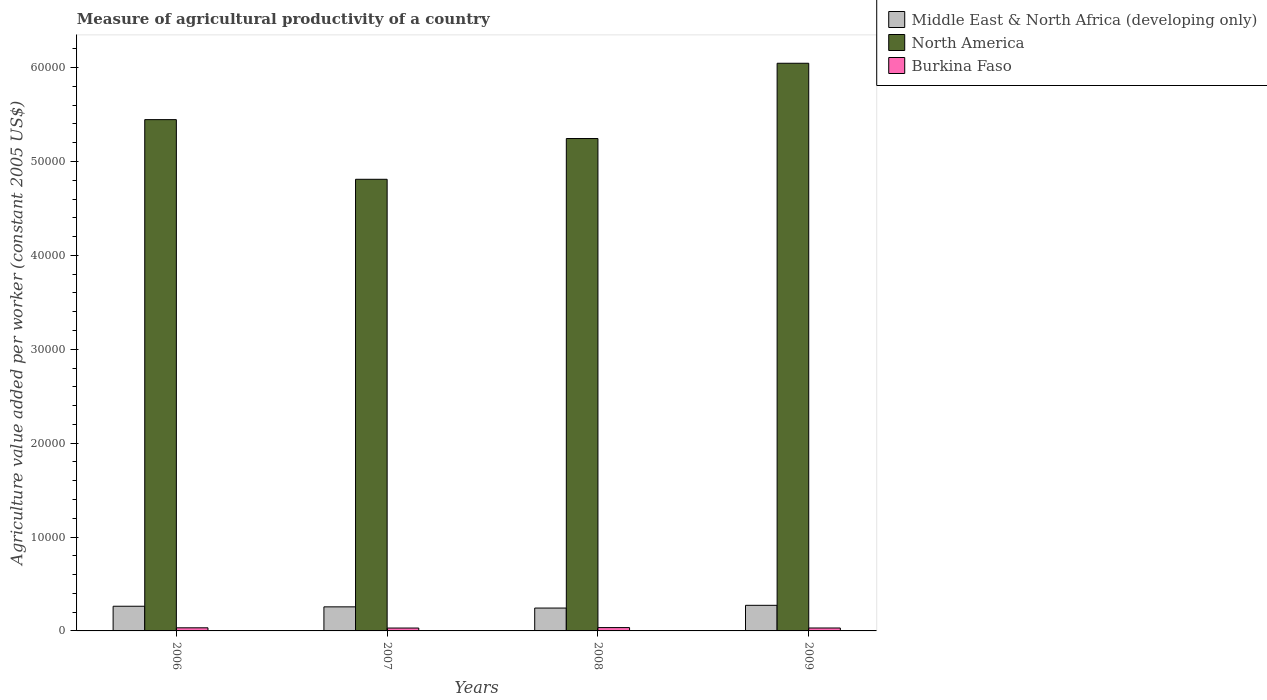How many groups of bars are there?
Give a very brief answer. 4. Are the number of bars per tick equal to the number of legend labels?
Offer a terse response. Yes. Are the number of bars on each tick of the X-axis equal?
Your answer should be very brief. Yes. What is the label of the 4th group of bars from the left?
Your answer should be very brief. 2009. In how many cases, is the number of bars for a given year not equal to the number of legend labels?
Your response must be concise. 0. What is the measure of agricultural productivity in Burkina Faso in 2008?
Your answer should be compact. 355.16. Across all years, what is the maximum measure of agricultural productivity in Middle East & North Africa (developing only)?
Provide a short and direct response. 2727.48. Across all years, what is the minimum measure of agricultural productivity in North America?
Provide a succinct answer. 4.81e+04. In which year was the measure of agricultural productivity in Middle East & North Africa (developing only) minimum?
Give a very brief answer. 2008. What is the total measure of agricultural productivity in North America in the graph?
Your answer should be very brief. 2.15e+05. What is the difference between the measure of agricultural productivity in Middle East & North Africa (developing only) in 2006 and that in 2008?
Offer a terse response. 192.32. What is the difference between the measure of agricultural productivity in Middle East & North Africa (developing only) in 2007 and the measure of agricultural productivity in Burkina Faso in 2006?
Your answer should be compact. 2232. What is the average measure of agricultural productivity in Middle East & North Africa (developing only) per year?
Give a very brief answer. 2588.76. In the year 2007, what is the difference between the measure of agricultural productivity in North America and measure of agricultural productivity in Burkina Faso?
Your answer should be compact. 4.78e+04. In how many years, is the measure of agricultural productivity in North America greater than 16000 US$?
Make the answer very short. 4. What is the ratio of the measure of agricultural productivity in North America in 2006 to that in 2007?
Keep it short and to the point. 1.13. Is the difference between the measure of agricultural productivity in North America in 2006 and 2008 greater than the difference between the measure of agricultural productivity in Burkina Faso in 2006 and 2008?
Your answer should be very brief. Yes. What is the difference between the highest and the second highest measure of agricultural productivity in Burkina Faso?
Your answer should be compact. 23.89. What is the difference between the highest and the lowest measure of agricultural productivity in Middle East & North Africa (developing only)?
Your response must be concise. 291.48. Is the sum of the measure of agricultural productivity in Middle East & North Africa (developing only) in 2007 and 2009 greater than the maximum measure of agricultural productivity in Burkina Faso across all years?
Your answer should be very brief. Yes. What does the 1st bar from the right in 2009 represents?
Your answer should be compact. Burkina Faso. Are the values on the major ticks of Y-axis written in scientific E-notation?
Offer a very short reply. No. Does the graph contain grids?
Your answer should be compact. No. How are the legend labels stacked?
Your answer should be very brief. Vertical. What is the title of the graph?
Make the answer very short. Measure of agricultural productivity of a country. What is the label or title of the Y-axis?
Provide a short and direct response. Agriculture value added per worker (constant 2005 US$). What is the Agriculture value added per worker (constant 2005 US$) in Middle East & North Africa (developing only) in 2006?
Your response must be concise. 2628.31. What is the Agriculture value added per worker (constant 2005 US$) of North America in 2006?
Your answer should be compact. 5.45e+04. What is the Agriculture value added per worker (constant 2005 US$) in Burkina Faso in 2006?
Your response must be concise. 331.27. What is the Agriculture value added per worker (constant 2005 US$) of Middle East & North Africa (developing only) in 2007?
Ensure brevity in your answer.  2563.27. What is the Agriculture value added per worker (constant 2005 US$) in North America in 2007?
Your response must be concise. 4.81e+04. What is the Agriculture value added per worker (constant 2005 US$) in Burkina Faso in 2007?
Offer a terse response. 306.75. What is the Agriculture value added per worker (constant 2005 US$) in Middle East & North Africa (developing only) in 2008?
Your answer should be compact. 2436. What is the Agriculture value added per worker (constant 2005 US$) of North America in 2008?
Provide a succinct answer. 5.24e+04. What is the Agriculture value added per worker (constant 2005 US$) in Burkina Faso in 2008?
Offer a very short reply. 355.16. What is the Agriculture value added per worker (constant 2005 US$) of Middle East & North Africa (developing only) in 2009?
Offer a terse response. 2727.48. What is the Agriculture value added per worker (constant 2005 US$) of North America in 2009?
Your answer should be compact. 6.05e+04. What is the Agriculture value added per worker (constant 2005 US$) of Burkina Faso in 2009?
Provide a succinct answer. 311.77. Across all years, what is the maximum Agriculture value added per worker (constant 2005 US$) of Middle East & North Africa (developing only)?
Offer a very short reply. 2727.48. Across all years, what is the maximum Agriculture value added per worker (constant 2005 US$) of North America?
Make the answer very short. 6.05e+04. Across all years, what is the maximum Agriculture value added per worker (constant 2005 US$) of Burkina Faso?
Your answer should be compact. 355.16. Across all years, what is the minimum Agriculture value added per worker (constant 2005 US$) of Middle East & North Africa (developing only)?
Your answer should be very brief. 2436. Across all years, what is the minimum Agriculture value added per worker (constant 2005 US$) in North America?
Your answer should be compact. 4.81e+04. Across all years, what is the minimum Agriculture value added per worker (constant 2005 US$) of Burkina Faso?
Your response must be concise. 306.75. What is the total Agriculture value added per worker (constant 2005 US$) of Middle East & North Africa (developing only) in the graph?
Your response must be concise. 1.04e+04. What is the total Agriculture value added per worker (constant 2005 US$) of North America in the graph?
Offer a very short reply. 2.15e+05. What is the total Agriculture value added per worker (constant 2005 US$) in Burkina Faso in the graph?
Your response must be concise. 1304.95. What is the difference between the Agriculture value added per worker (constant 2005 US$) in Middle East & North Africa (developing only) in 2006 and that in 2007?
Your response must be concise. 65.05. What is the difference between the Agriculture value added per worker (constant 2005 US$) of North America in 2006 and that in 2007?
Offer a very short reply. 6354.14. What is the difference between the Agriculture value added per worker (constant 2005 US$) of Burkina Faso in 2006 and that in 2007?
Provide a short and direct response. 24.52. What is the difference between the Agriculture value added per worker (constant 2005 US$) in Middle East & North Africa (developing only) in 2006 and that in 2008?
Provide a succinct answer. 192.32. What is the difference between the Agriculture value added per worker (constant 2005 US$) in North America in 2006 and that in 2008?
Provide a short and direct response. 2011.06. What is the difference between the Agriculture value added per worker (constant 2005 US$) in Burkina Faso in 2006 and that in 2008?
Keep it short and to the point. -23.89. What is the difference between the Agriculture value added per worker (constant 2005 US$) in Middle East & North Africa (developing only) in 2006 and that in 2009?
Make the answer very short. -99.16. What is the difference between the Agriculture value added per worker (constant 2005 US$) of North America in 2006 and that in 2009?
Offer a terse response. -6004.46. What is the difference between the Agriculture value added per worker (constant 2005 US$) of Burkina Faso in 2006 and that in 2009?
Your response must be concise. 19.5. What is the difference between the Agriculture value added per worker (constant 2005 US$) in Middle East & North Africa (developing only) in 2007 and that in 2008?
Provide a short and direct response. 127.27. What is the difference between the Agriculture value added per worker (constant 2005 US$) in North America in 2007 and that in 2008?
Keep it short and to the point. -4343.08. What is the difference between the Agriculture value added per worker (constant 2005 US$) in Burkina Faso in 2007 and that in 2008?
Your response must be concise. -48.41. What is the difference between the Agriculture value added per worker (constant 2005 US$) of Middle East & North Africa (developing only) in 2007 and that in 2009?
Ensure brevity in your answer.  -164.21. What is the difference between the Agriculture value added per worker (constant 2005 US$) of North America in 2007 and that in 2009?
Provide a short and direct response. -1.24e+04. What is the difference between the Agriculture value added per worker (constant 2005 US$) of Burkina Faso in 2007 and that in 2009?
Ensure brevity in your answer.  -5.02. What is the difference between the Agriculture value added per worker (constant 2005 US$) of Middle East & North Africa (developing only) in 2008 and that in 2009?
Ensure brevity in your answer.  -291.48. What is the difference between the Agriculture value added per worker (constant 2005 US$) of North America in 2008 and that in 2009?
Provide a succinct answer. -8015.53. What is the difference between the Agriculture value added per worker (constant 2005 US$) of Burkina Faso in 2008 and that in 2009?
Offer a very short reply. 43.39. What is the difference between the Agriculture value added per worker (constant 2005 US$) in Middle East & North Africa (developing only) in 2006 and the Agriculture value added per worker (constant 2005 US$) in North America in 2007?
Offer a terse response. -4.55e+04. What is the difference between the Agriculture value added per worker (constant 2005 US$) in Middle East & North Africa (developing only) in 2006 and the Agriculture value added per worker (constant 2005 US$) in Burkina Faso in 2007?
Give a very brief answer. 2321.57. What is the difference between the Agriculture value added per worker (constant 2005 US$) of North America in 2006 and the Agriculture value added per worker (constant 2005 US$) of Burkina Faso in 2007?
Make the answer very short. 5.41e+04. What is the difference between the Agriculture value added per worker (constant 2005 US$) in Middle East & North Africa (developing only) in 2006 and the Agriculture value added per worker (constant 2005 US$) in North America in 2008?
Provide a succinct answer. -4.98e+04. What is the difference between the Agriculture value added per worker (constant 2005 US$) of Middle East & North Africa (developing only) in 2006 and the Agriculture value added per worker (constant 2005 US$) of Burkina Faso in 2008?
Your response must be concise. 2273.15. What is the difference between the Agriculture value added per worker (constant 2005 US$) of North America in 2006 and the Agriculture value added per worker (constant 2005 US$) of Burkina Faso in 2008?
Provide a succinct answer. 5.41e+04. What is the difference between the Agriculture value added per worker (constant 2005 US$) of Middle East & North Africa (developing only) in 2006 and the Agriculture value added per worker (constant 2005 US$) of North America in 2009?
Your answer should be compact. -5.78e+04. What is the difference between the Agriculture value added per worker (constant 2005 US$) in Middle East & North Africa (developing only) in 2006 and the Agriculture value added per worker (constant 2005 US$) in Burkina Faso in 2009?
Make the answer very short. 2316.55. What is the difference between the Agriculture value added per worker (constant 2005 US$) in North America in 2006 and the Agriculture value added per worker (constant 2005 US$) in Burkina Faso in 2009?
Offer a very short reply. 5.41e+04. What is the difference between the Agriculture value added per worker (constant 2005 US$) in Middle East & North Africa (developing only) in 2007 and the Agriculture value added per worker (constant 2005 US$) in North America in 2008?
Provide a short and direct response. -4.99e+04. What is the difference between the Agriculture value added per worker (constant 2005 US$) in Middle East & North Africa (developing only) in 2007 and the Agriculture value added per worker (constant 2005 US$) in Burkina Faso in 2008?
Offer a terse response. 2208.11. What is the difference between the Agriculture value added per worker (constant 2005 US$) of North America in 2007 and the Agriculture value added per worker (constant 2005 US$) of Burkina Faso in 2008?
Offer a very short reply. 4.77e+04. What is the difference between the Agriculture value added per worker (constant 2005 US$) of Middle East & North Africa (developing only) in 2007 and the Agriculture value added per worker (constant 2005 US$) of North America in 2009?
Your answer should be compact. -5.79e+04. What is the difference between the Agriculture value added per worker (constant 2005 US$) in Middle East & North Africa (developing only) in 2007 and the Agriculture value added per worker (constant 2005 US$) in Burkina Faso in 2009?
Make the answer very short. 2251.5. What is the difference between the Agriculture value added per worker (constant 2005 US$) of North America in 2007 and the Agriculture value added per worker (constant 2005 US$) of Burkina Faso in 2009?
Your answer should be compact. 4.78e+04. What is the difference between the Agriculture value added per worker (constant 2005 US$) of Middle East & North Africa (developing only) in 2008 and the Agriculture value added per worker (constant 2005 US$) of North America in 2009?
Your response must be concise. -5.80e+04. What is the difference between the Agriculture value added per worker (constant 2005 US$) in Middle East & North Africa (developing only) in 2008 and the Agriculture value added per worker (constant 2005 US$) in Burkina Faso in 2009?
Your answer should be compact. 2124.23. What is the difference between the Agriculture value added per worker (constant 2005 US$) of North America in 2008 and the Agriculture value added per worker (constant 2005 US$) of Burkina Faso in 2009?
Make the answer very short. 5.21e+04. What is the average Agriculture value added per worker (constant 2005 US$) of Middle East & North Africa (developing only) per year?
Your answer should be very brief. 2588.76. What is the average Agriculture value added per worker (constant 2005 US$) of North America per year?
Your answer should be very brief. 5.39e+04. What is the average Agriculture value added per worker (constant 2005 US$) in Burkina Faso per year?
Provide a succinct answer. 326.24. In the year 2006, what is the difference between the Agriculture value added per worker (constant 2005 US$) of Middle East & North Africa (developing only) and Agriculture value added per worker (constant 2005 US$) of North America?
Offer a very short reply. -5.18e+04. In the year 2006, what is the difference between the Agriculture value added per worker (constant 2005 US$) in Middle East & North Africa (developing only) and Agriculture value added per worker (constant 2005 US$) in Burkina Faso?
Keep it short and to the point. 2297.04. In the year 2006, what is the difference between the Agriculture value added per worker (constant 2005 US$) in North America and Agriculture value added per worker (constant 2005 US$) in Burkina Faso?
Make the answer very short. 5.41e+04. In the year 2007, what is the difference between the Agriculture value added per worker (constant 2005 US$) of Middle East & North Africa (developing only) and Agriculture value added per worker (constant 2005 US$) of North America?
Provide a short and direct response. -4.55e+04. In the year 2007, what is the difference between the Agriculture value added per worker (constant 2005 US$) of Middle East & North Africa (developing only) and Agriculture value added per worker (constant 2005 US$) of Burkina Faso?
Your answer should be very brief. 2256.52. In the year 2007, what is the difference between the Agriculture value added per worker (constant 2005 US$) of North America and Agriculture value added per worker (constant 2005 US$) of Burkina Faso?
Offer a very short reply. 4.78e+04. In the year 2008, what is the difference between the Agriculture value added per worker (constant 2005 US$) of Middle East & North Africa (developing only) and Agriculture value added per worker (constant 2005 US$) of North America?
Your response must be concise. -5.00e+04. In the year 2008, what is the difference between the Agriculture value added per worker (constant 2005 US$) of Middle East & North Africa (developing only) and Agriculture value added per worker (constant 2005 US$) of Burkina Faso?
Offer a very short reply. 2080.83. In the year 2008, what is the difference between the Agriculture value added per worker (constant 2005 US$) in North America and Agriculture value added per worker (constant 2005 US$) in Burkina Faso?
Make the answer very short. 5.21e+04. In the year 2009, what is the difference between the Agriculture value added per worker (constant 2005 US$) in Middle East & North Africa (developing only) and Agriculture value added per worker (constant 2005 US$) in North America?
Give a very brief answer. -5.77e+04. In the year 2009, what is the difference between the Agriculture value added per worker (constant 2005 US$) of Middle East & North Africa (developing only) and Agriculture value added per worker (constant 2005 US$) of Burkina Faso?
Keep it short and to the point. 2415.71. In the year 2009, what is the difference between the Agriculture value added per worker (constant 2005 US$) in North America and Agriculture value added per worker (constant 2005 US$) in Burkina Faso?
Offer a very short reply. 6.01e+04. What is the ratio of the Agriculture value added per worker (constant 2005 US$) in Middle East & North Africa (developing only) in 2006 to that in 2007?
Offer a terse response. 1.03. What is the ratio of the Agriculture value added per worker (constant 2005 US$) of North America in 2006 to that in 2007?
Your answer should be compact. 1.13. What is the ratio of the Agriculture value added per worker (constant 2005 US$) in Burkina Faso in 2006 to that in 2007?
Keep it short and to the point. 1.08. What is the ratio of the Agriculture value added per worker (constant 2005 US$) in Middle East & North Africa (developing only) in 2006 to that in 2008?
Offer a very short reply. 1.08. What is the ratio of the Agriculture value added per worker (constant 2005 US$) in North America in 2006 to that in 2008?
Ensure brevity in your answer.  1.04. What is the ratio of the Agriculture value added per worker (constant 2005 US$) of Burkina Faso in 2006 to that in 2008?
Provide a short and direct response. 0.93. What is the ratio of the Agriculture value added per worker (constant 2005 US$) of Middle East & North Africa (developing only) in 2006 to that in 2009?
Provide a short and direct response. 0.96. What is the ratio of the Agriculture value added per worker (constant 2005 US$) in North America in 2006 to that in 2009?
Your answer should be compact. 0.9. What is the ratio of the Agriculture value added per worker (constant 2005 US$) of Burkina Faso in 2006 to that in 2009?
Keep it short and to the point. 1.06. What is the ratio of the Agriculture value added per worker (constant 2005 US$) of Middle East & North Africa (developing only) in 2007 to that in 2008?
Your response must be concise. 1.05. What is the ratio of the Agriculture value added per worker (constant 2005 US$) of North America in 2007 to that in 2008?
Ensure brevity in your answer.  0.92. What is the ratio of the Agriculture value added per worker (constant 2005 US$) of Burkina Faso in 2007 to that in 2008?
Ensure brevity in your answer.  0.86. What is the ratio of the Agriculture value added per worker (constant 2005 US$) in Middle East & North Africa (developing only) in 2007 to that in 2009?
Your answer should be very brief. 0.94. What is the ratio of the Agriculture value added per worker (constant 2005 US$) in North America in 2007 to that in 2009?
Your answer should be very brief. 0.8. What is the ratio of the Agriculture value added per worker (constant 2005 US$) in Burkina Faso in 2007 to that in 2009?
Provide a short and direct response. 0.98. What is the ratio of the Agriculture value added per worker (constant 2005 US$) in Middle East & North Africa (developing only) in 2008 to that in 2009?
Offer a very short reply. 0.89. What is the ratio of the Agriculture value added per worker (constant 2005 US$) in North America in 2008 to that in 2009?
Provide a succinct answer. 0.87. What is the ratio of the Agriculture value added per worker (constant 2005 US$) in Burkina Faso in 2008 to that in 2009?
Offer a very short reply. 1.14. What is the difference between the highest and the second highest Agriculture value added per worker (constant 2005 US$) in Middle East & North Africa (developing only)?
Make the answer very short. 99.16. What is the difference between the highest and the second highest Agriculture value added per worker (constant 2005 US$) of North America?
Make the answer very short. 6004.46. What is the difference between the highest and the second highest Agriculture value added per worker (constant 2005 US$) of Burkina Faso?
Ensure brevity in your answer.  23.89. What is the difference between the highest and the lowest Agriculture value added per worker (constant 2005 US$) in Middle East & North Africa (developing only)?
Offer a very short reply. 291.48. What is the difference between the highest and the lowest Agriculture value added per worker (constant 2005 US$) in North America?
Offer a terse response. 1.24e+04. What is the difference between the highest and the lowest Agriculture value added per worker (constant 2005 US$) in Burkina Faso?
Offer a terse response. 48.41. 